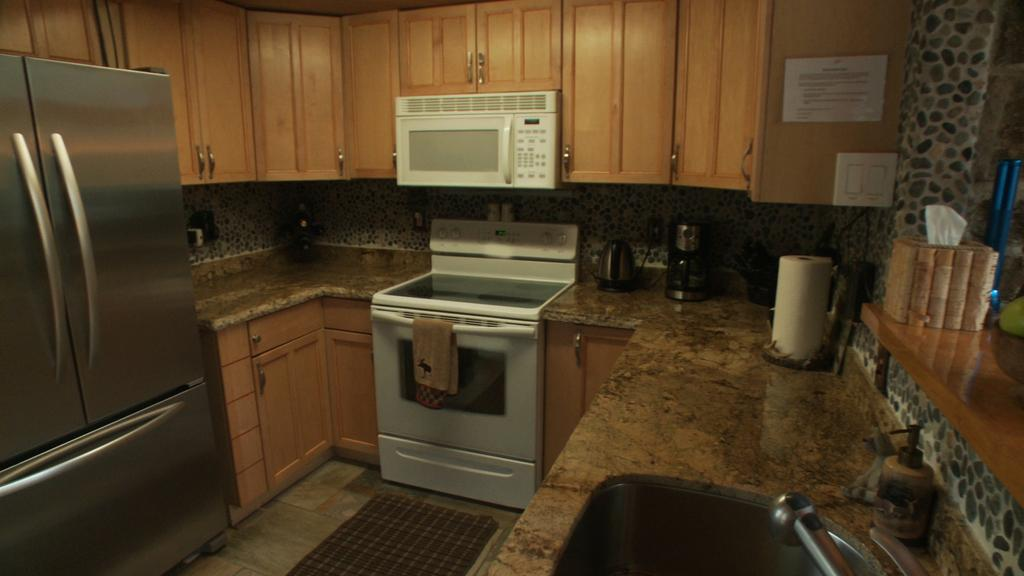What type of room is shown in the image? The image depicts a kitchen. What appliances can be seen in the kitchen? There is a washing machine and an oven in the kitchen. What item is used for storing food in the kitchen? There is a fridge in the kitchen. What type of storage is available in the kitchen? There are cupboards in the kitchen. Is there any decoration on the cupboards? Yes, there is a poster on one of the cupboards. Can you see any crayons on the poster in the image? There is no mention of crayons in the image, and the provided facts do not indicate their presence. 